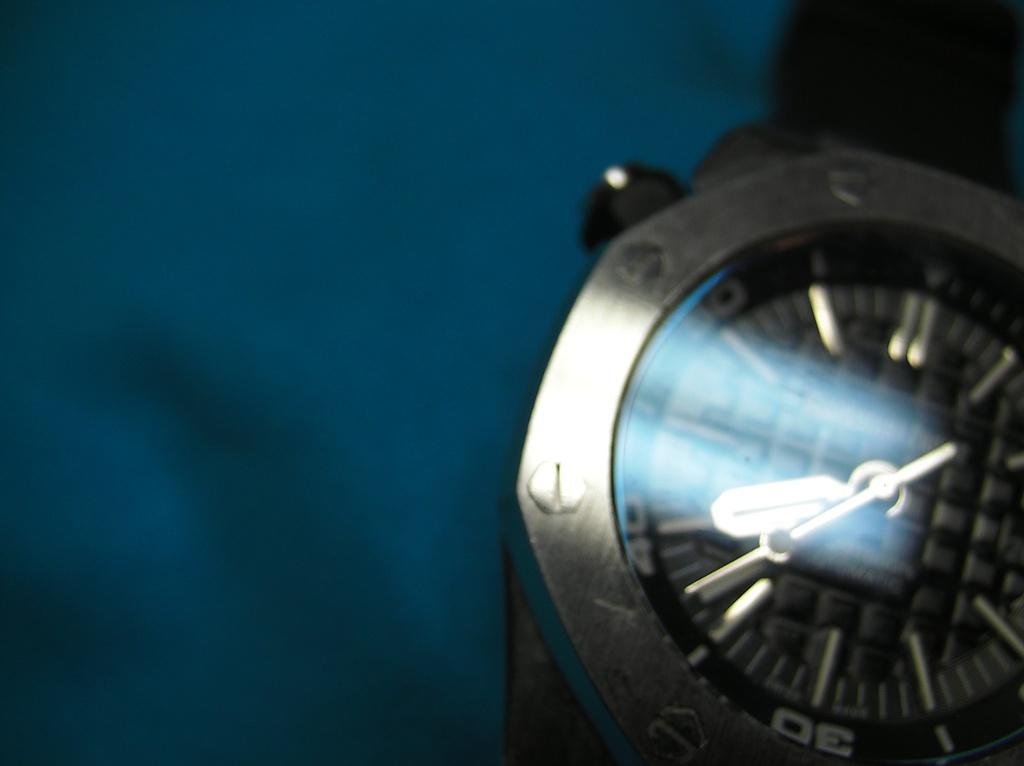<image>
Render a clear and concise summary of the photo. A dark grey watch that shows it to be 7:37. 